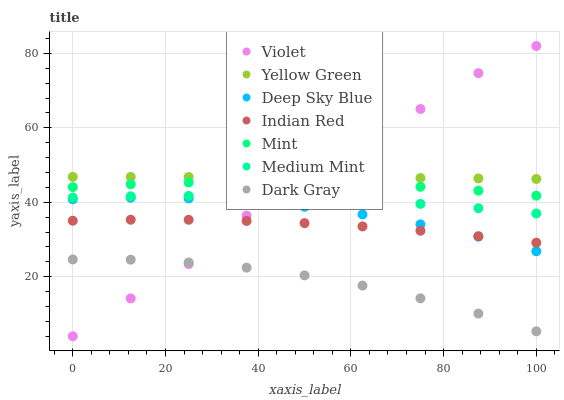Does Dark Gray have the minimum area under the curve?
Answer yes or no. Yes. Does Yellow Green have the maximum area under the curve?
Answer yes or no. Yes. Does Yellow Green have the minimum area under the curve?
Answer yes or no. No. Does Dark Gray have the maximum area under the curve?
Answer yes or no. No. Is Yellow Green the smoothest?
Answer yes or no. Yes. Is Violet the roughest?
Answer yes or no. Yes. Is Dark Gray the smoothest?
Answer yes or no. No. Is Dark Gray the roughest?
Answer yes or no. No. Does Violet have the lowest value?
Answer yes or no. Yes. Does Dark Gray have the lowest value?
Answer yes or no. No. Does Violet have the highest value?
Answer yes or no. Yes. Does Yellow Green have the highest value?
Answer yes or no. No. Is Indian Red less than Medium Mint?
Answer yes or no. Yes. Is Medium Mint greater than Dark Gray?
Answer yes or no. Yes. Does Violet intersect Indian Red?
Answer yes or no. Yes. Is Violet less than Indian Red?
Answer yes or no. No. Is Violet greater than Indian Red?
Answer yes or no. No. Does Indian Red intersect Medium Mint?
Answer yes or no. No. 